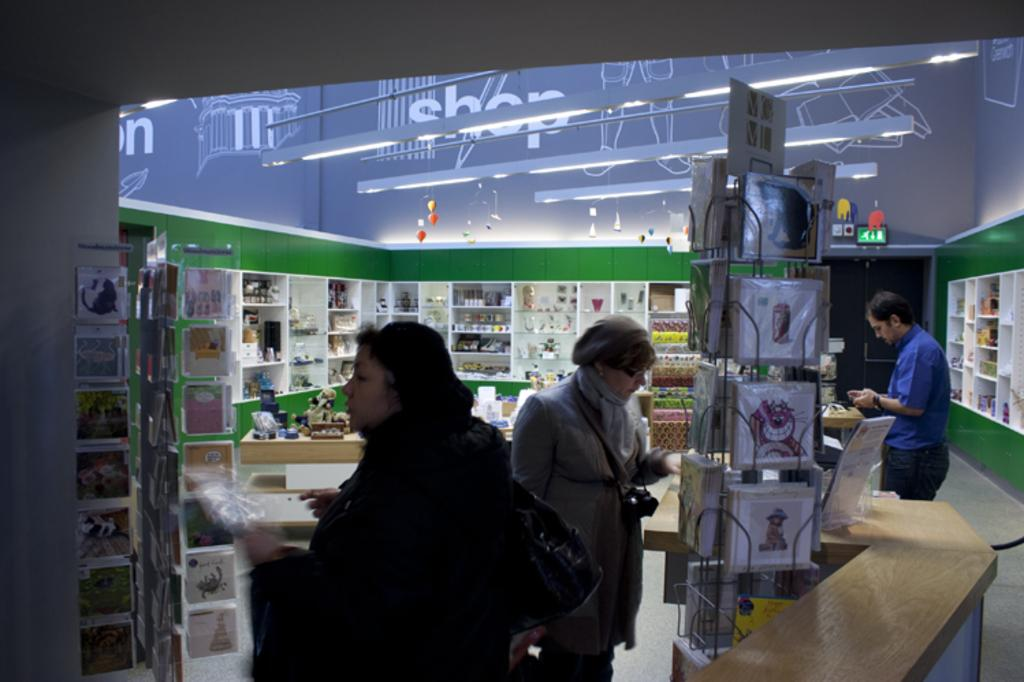<image>
Share a concise interpretation of the image provided. people in a store with the word SHOP on the walls browse the goods 